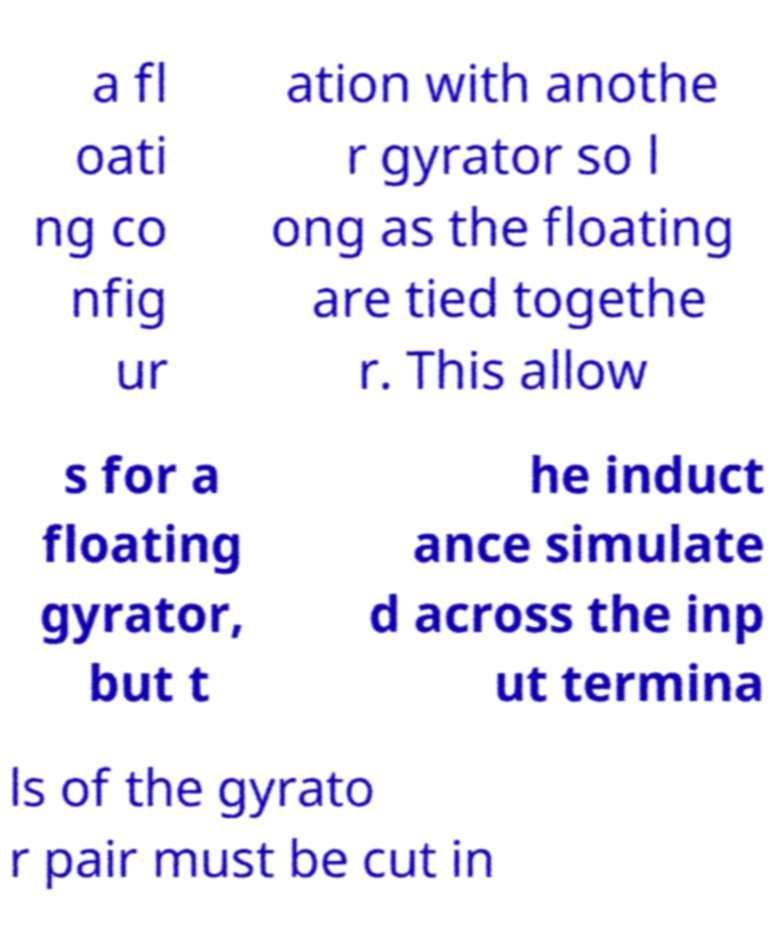Please read and relay the text visible in this image. What does it say? a fl oati ng co nfig ur ation with anothe r gyrator so l ong as the floating are tied togethe r. This allow s for a floating gyrator, but t he induct ance simulate d across the inp ut termina ls of the gyrato r pair must be cut in 